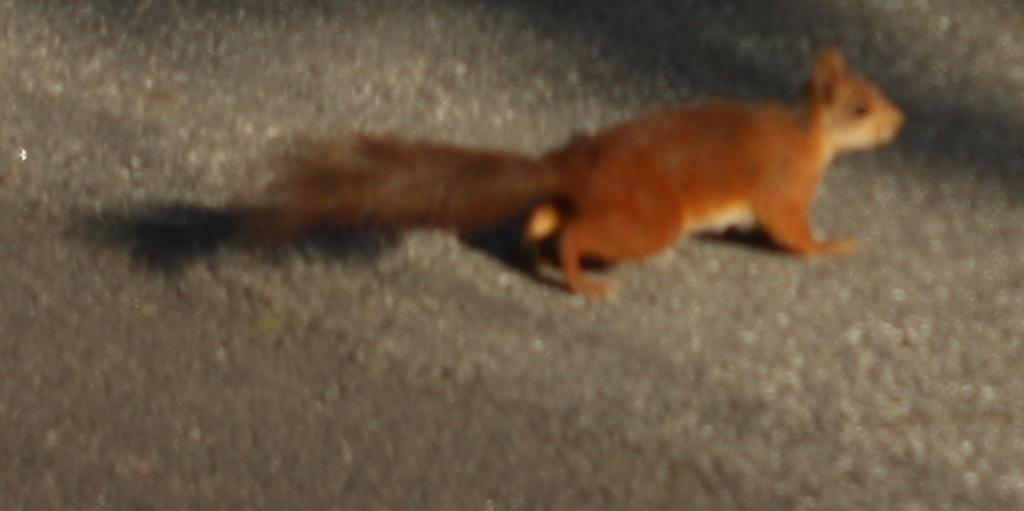What type of animal is in the image? The facts provided do not specify the type of animal, only that it has brown and cream coloring and is on a grey surface. Can you describe the coloring of the animal in the image? The animal has brown and cream coloring. What is the surface the animal is on in the image? The animal is on a grey surface. What type of soda is the animal drinking in the image? There is no soda present in the image, and the animal is not shown drinking anything. 